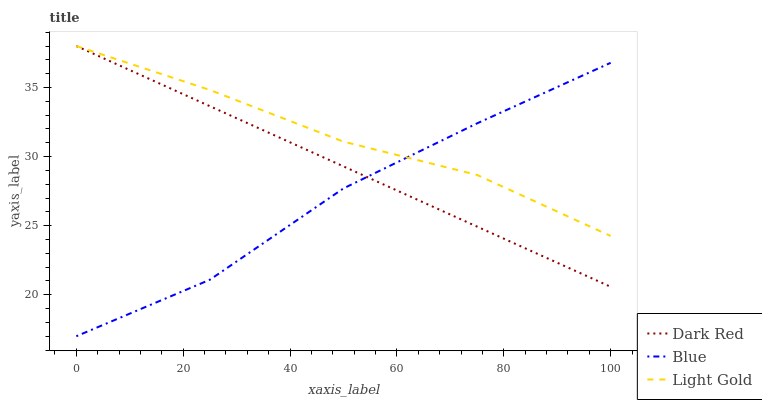Does Blue have the minimum area under the curve?
Answer yes or no. Yes. Does Light Gold have the maximum area under the curve?
Answer yes or no. Yes. Does Dark Red have the minimum area under the curve?
Answer yes or no. No. Does Dark Red have the maximum area under the curve?
Answer yes or no. No. Is Dark Red the smoothest?
Answer yes or no. Yes. Is Blue the roughest?
Answer yes or no. Yes. Is Light Gold the smoothest?
Answer yes or no. No. Is Light Gold the roughest?
Answer yes or no. No. Does Blue have the lowest value?
Answer yes or no. Yes. Does Dark Red have the lowest value?
Answer yes or no. No. Does Light Gold have the highest value?
Answer yes or no. Yes. Does Dark Red intersect Blue?
Answer yes or no. Yes. Is Dark Red less than Blue?
Answer yes or no. No. Is Dark Red greater than Blue?
Answer yes or no. No. 